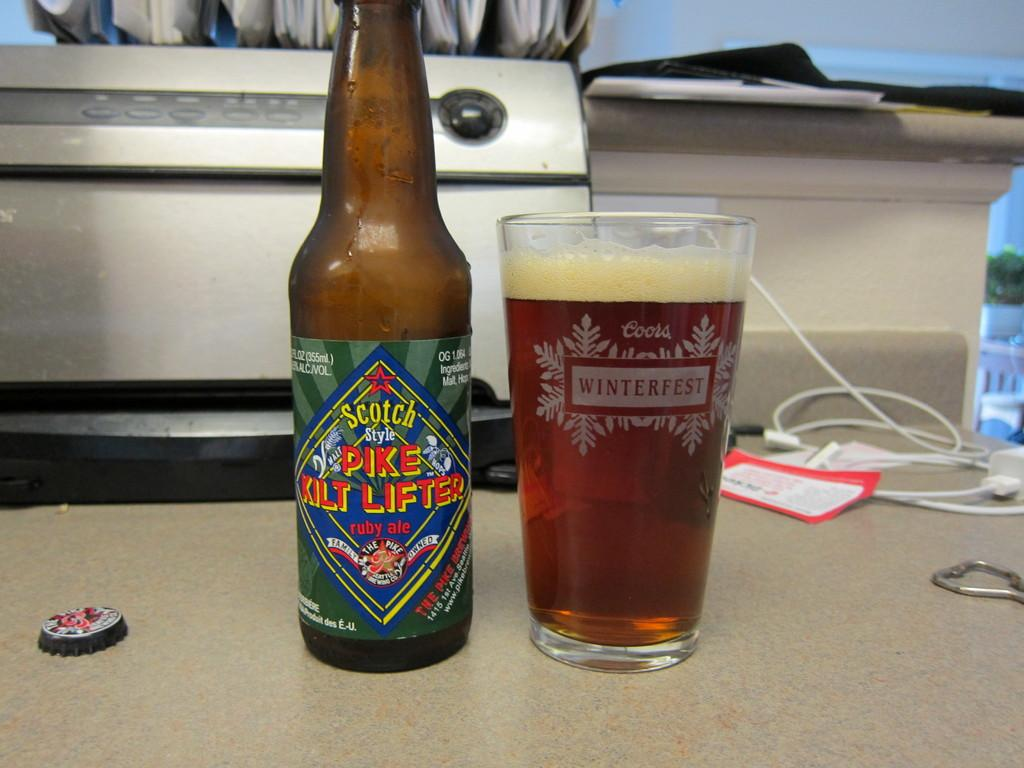Provide a one-sentence caption for the provided image. A bottle of Scotch Style PIKE KILT LIFTER ruby ale is on a table and glass of it is next to it with Coors WINTERFEST on the glass itself. 